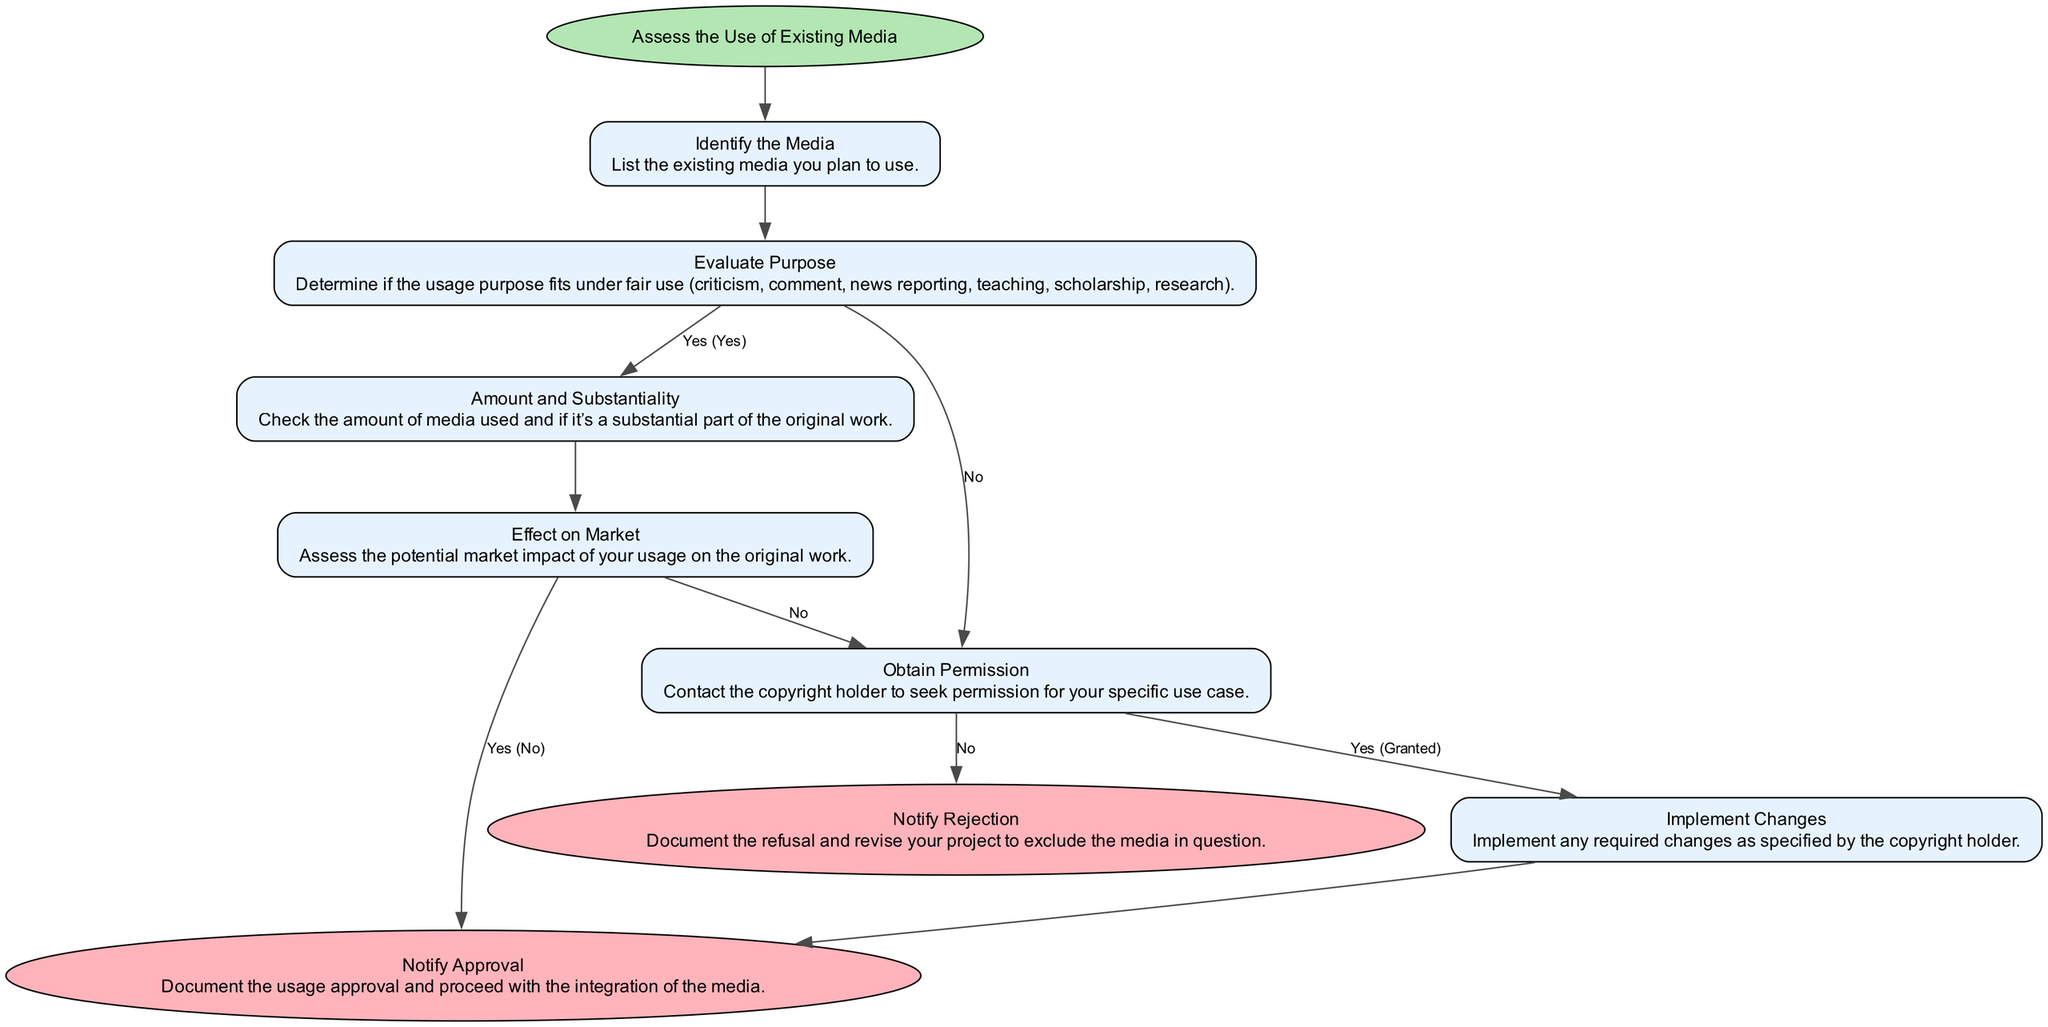What is the first step in the process? The first step is labeled "Assess the Use of Existing Media" which sets the context for the entire flowchart.
Answer: Assess the Use of Existing Media How many total steps are there in the diagram? Counting all the steps listed in the diagram, including both the main steps and notifications, there are a total of 7 steps.
Answer: 7 What is the purpose of the second step? The second step is to evaluate whether the purpose of the media usage fits under the fair use categories such as criticism, comment, news reporting, and so on.
Answer: Evaluate Purpose What happens if the effect on the market is assessed as "No"? If the market effect is assessed as "No", the flow moves to the "Notify Approval" step, indicating that usage can proceed without any concerns over copyright infringement.
Answer: Notify Approval What is required after obtaining permission from the copyright holder? After obtaining permission, it is necessary to implement any changes as specified by the copyright holder, completing the agreement and ensuring compliance with any terms.
Answer: Implement Changes What is the outcome if permission to use the media is granted? If permission is granted, the next step is to implement changes as specified by the copyright holder, allowing for smooth integration of the media.
Answer: Implement Changes How does one document a refusal of permission? A refusal of permission is documented at the "Notify Rejection" step, where the project needs to be revised to exclude the media in question, thus ensuring compliance with copyright laws.
Answer: Notify Rejection Which step follows after assessing the amount and substantiality of the media used? The next step that follows is to assess the potential market impact of the usage on the original work, which is a critical factor in determining fair use.
Answer: Effect on Market What links the step "Evaluate Purpose" to "Amount and Substantiality"? They are linked by a condition where if the purpose fits under fair use, the flow moves on to "Amount and Substantiality"; otherwise, it goes to "Obtain Permission".
Answer: Amount and Substantiality 